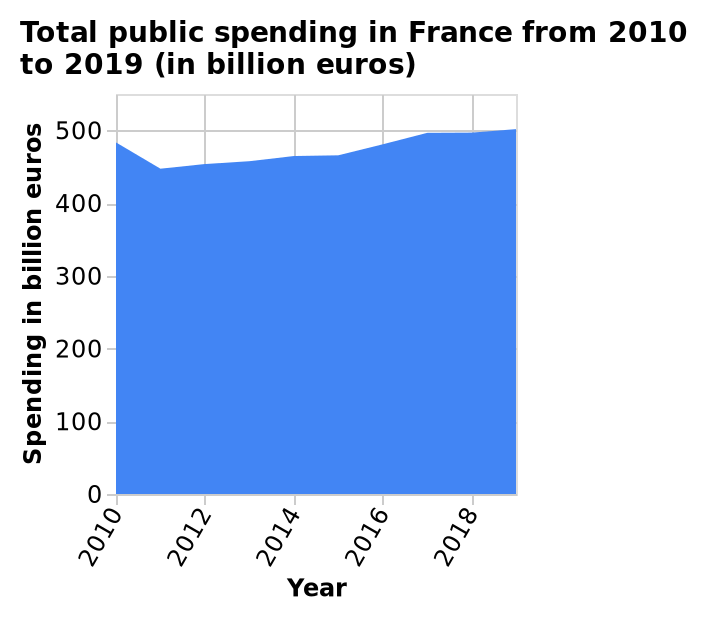<image>
What is the label of the y-axis on the area chart? The label of the y-axis on the area chart is "Spending in billion euros". Offer a thorough analysis of the image. There was a decline in public spending in France from 2010 to 2011. Since 2011, public spending has increased slowly over many years. In 2017, spending began to stay consistent at 500 billion euros. How has public spending in France changed since 2011?  Since 2011, public spending has increased slowly over many years. please enumerates aspects of the construction of the chart Here a is a area chart labeled Total public spending in France from 2010 to 2019 (in billion euros). The y-axis shows Spending in billion euros as linear scale of range 0 to 500 while the x-axis shows Year as linear scale of range 2010 to 2018. How much was the consistent public spending in France in 2017? The consistent public spending in France in 2017 was 500 billion euros. Is the y-axis of the area chart labeled Total public spending in France from 2010 to 2019 shown as a logarithmic scale of range 0 to 1000? No.Here a is a area chart labeled Total public spending in France from 2010 to 2019 (in billion euros). The y-axis shows Spending in billion euros as linear scale of range 0 to 500 while the x-axis shows Year as linear scale of range 2010 to 2018. 